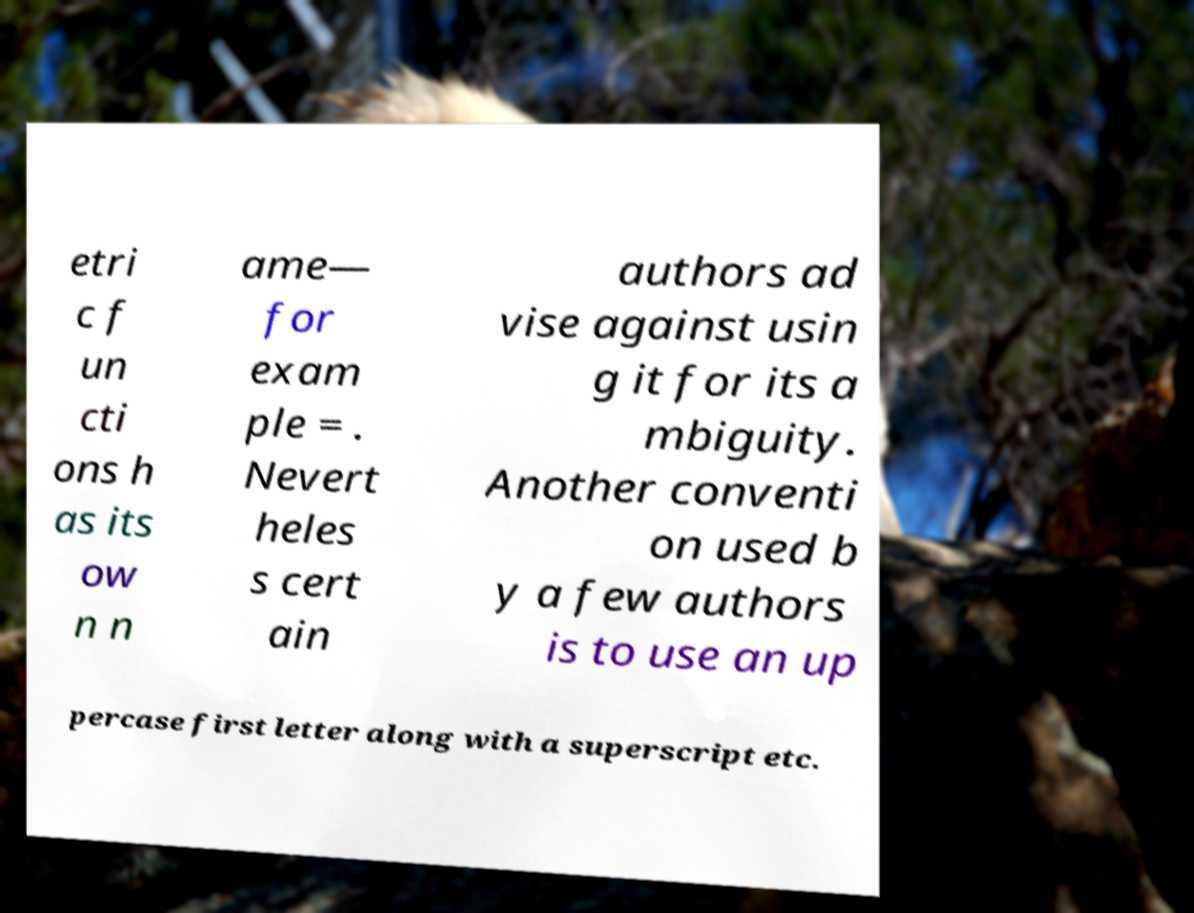Please identify and transcribe the text found in this image. etri c f un cti ons h as its ow n n ame— for exam ple = . Nevert heles s cert ain authors ad vise against usin g it for its a mbiguity. Another conventi on used b y a few authors is to use an up percase first letter along with a superscript etc. 